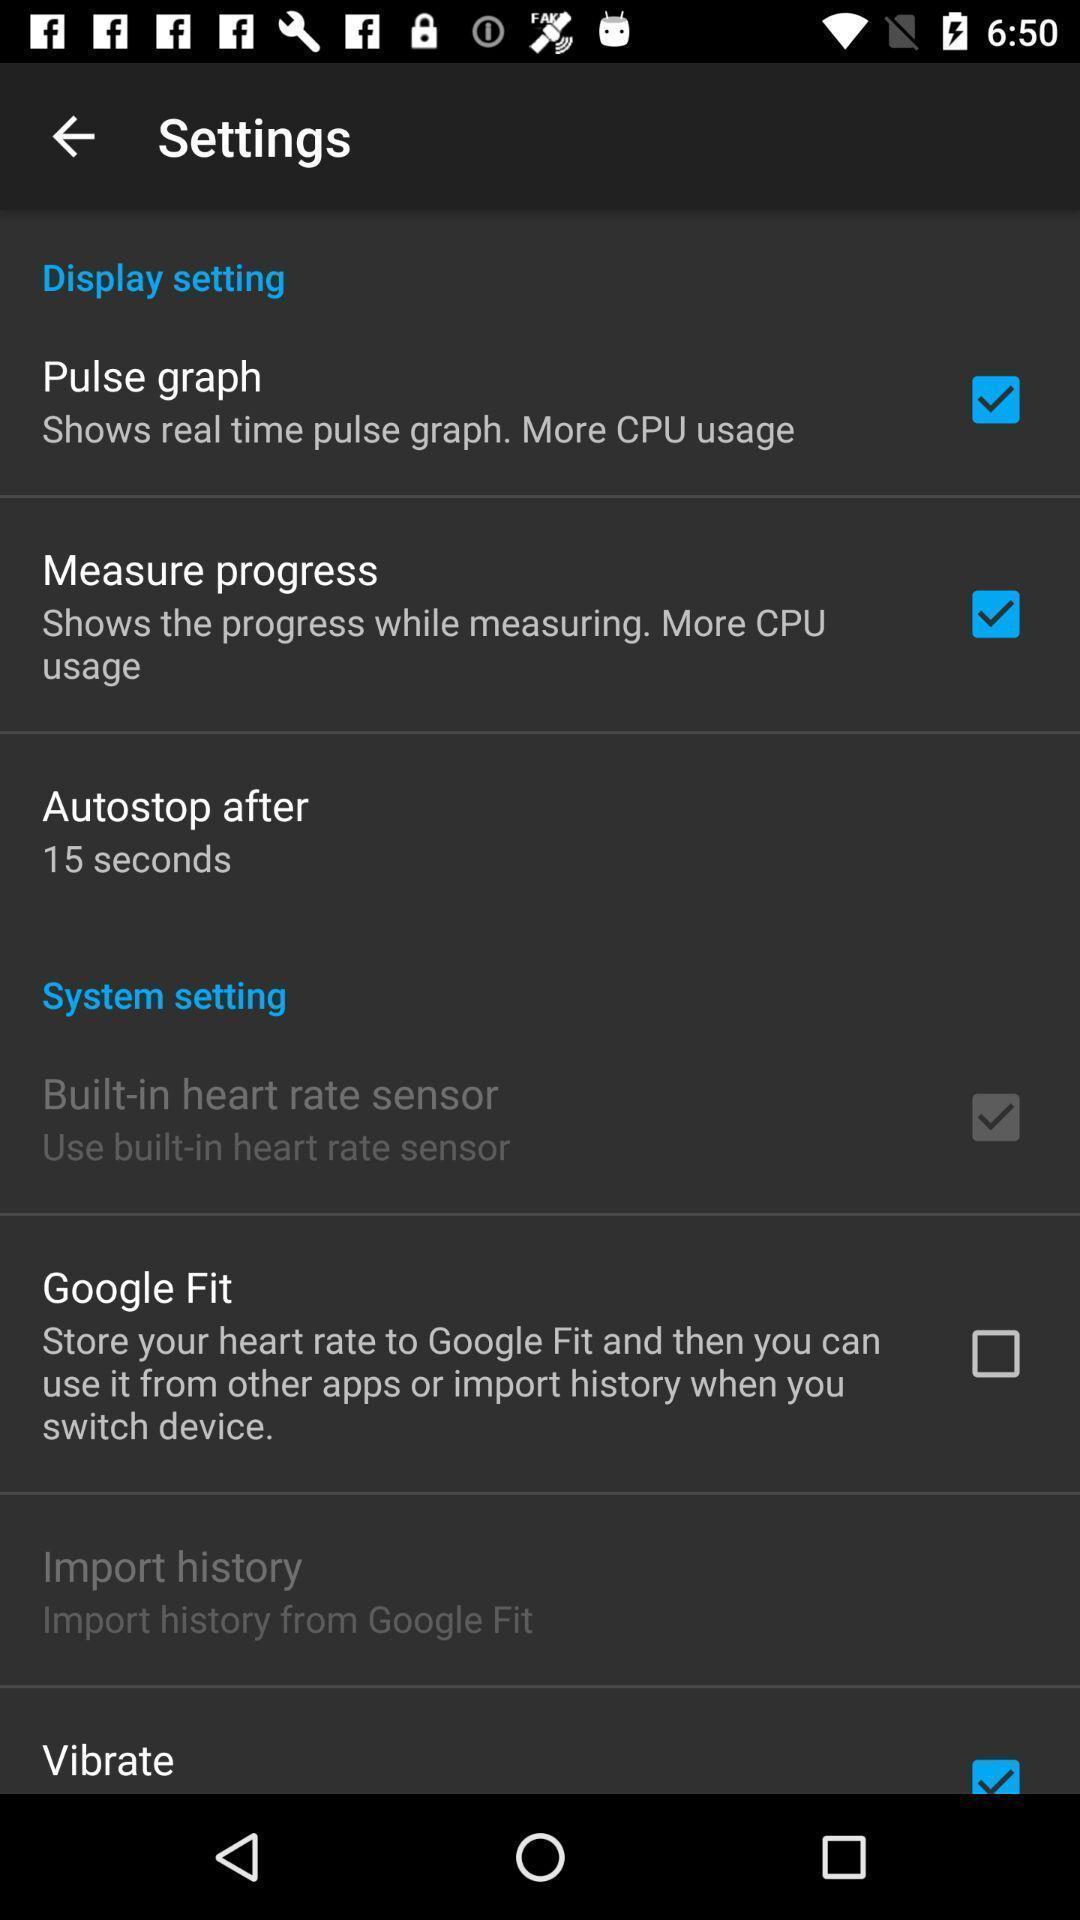What is the overall content of this screenshot? Page showing list of options under settings. 